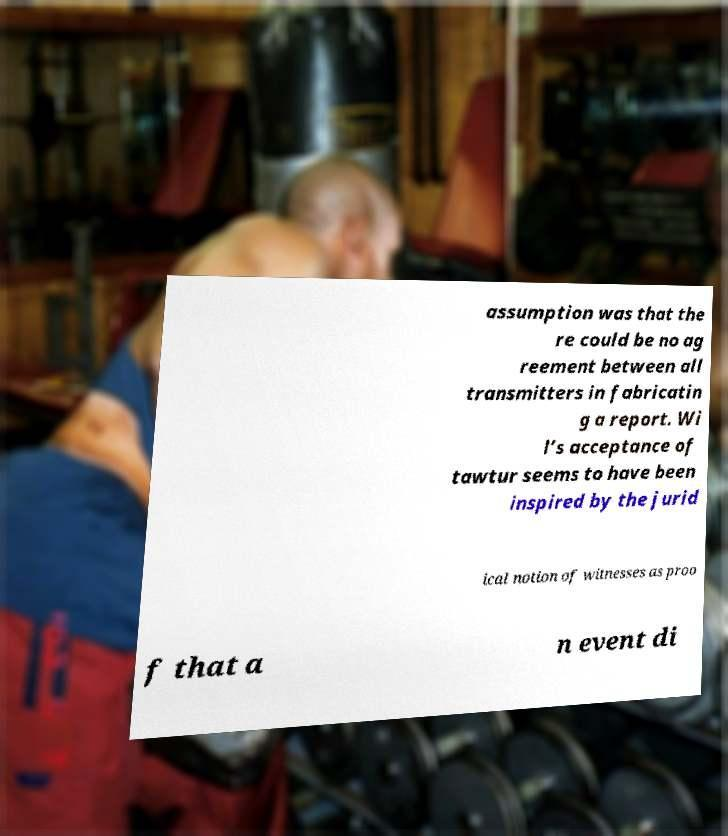Can you read and provide the text displayed in the image?This photo seems to have some interesting text. Can you extract and type it out for me? assumption was that the re could be no ag reement between all transmitters in fabricatin g a report. Wi l’s acceptance of tawtur seems to have been inspired by the jurid ical notion of witnesses as proo f that a n event di 